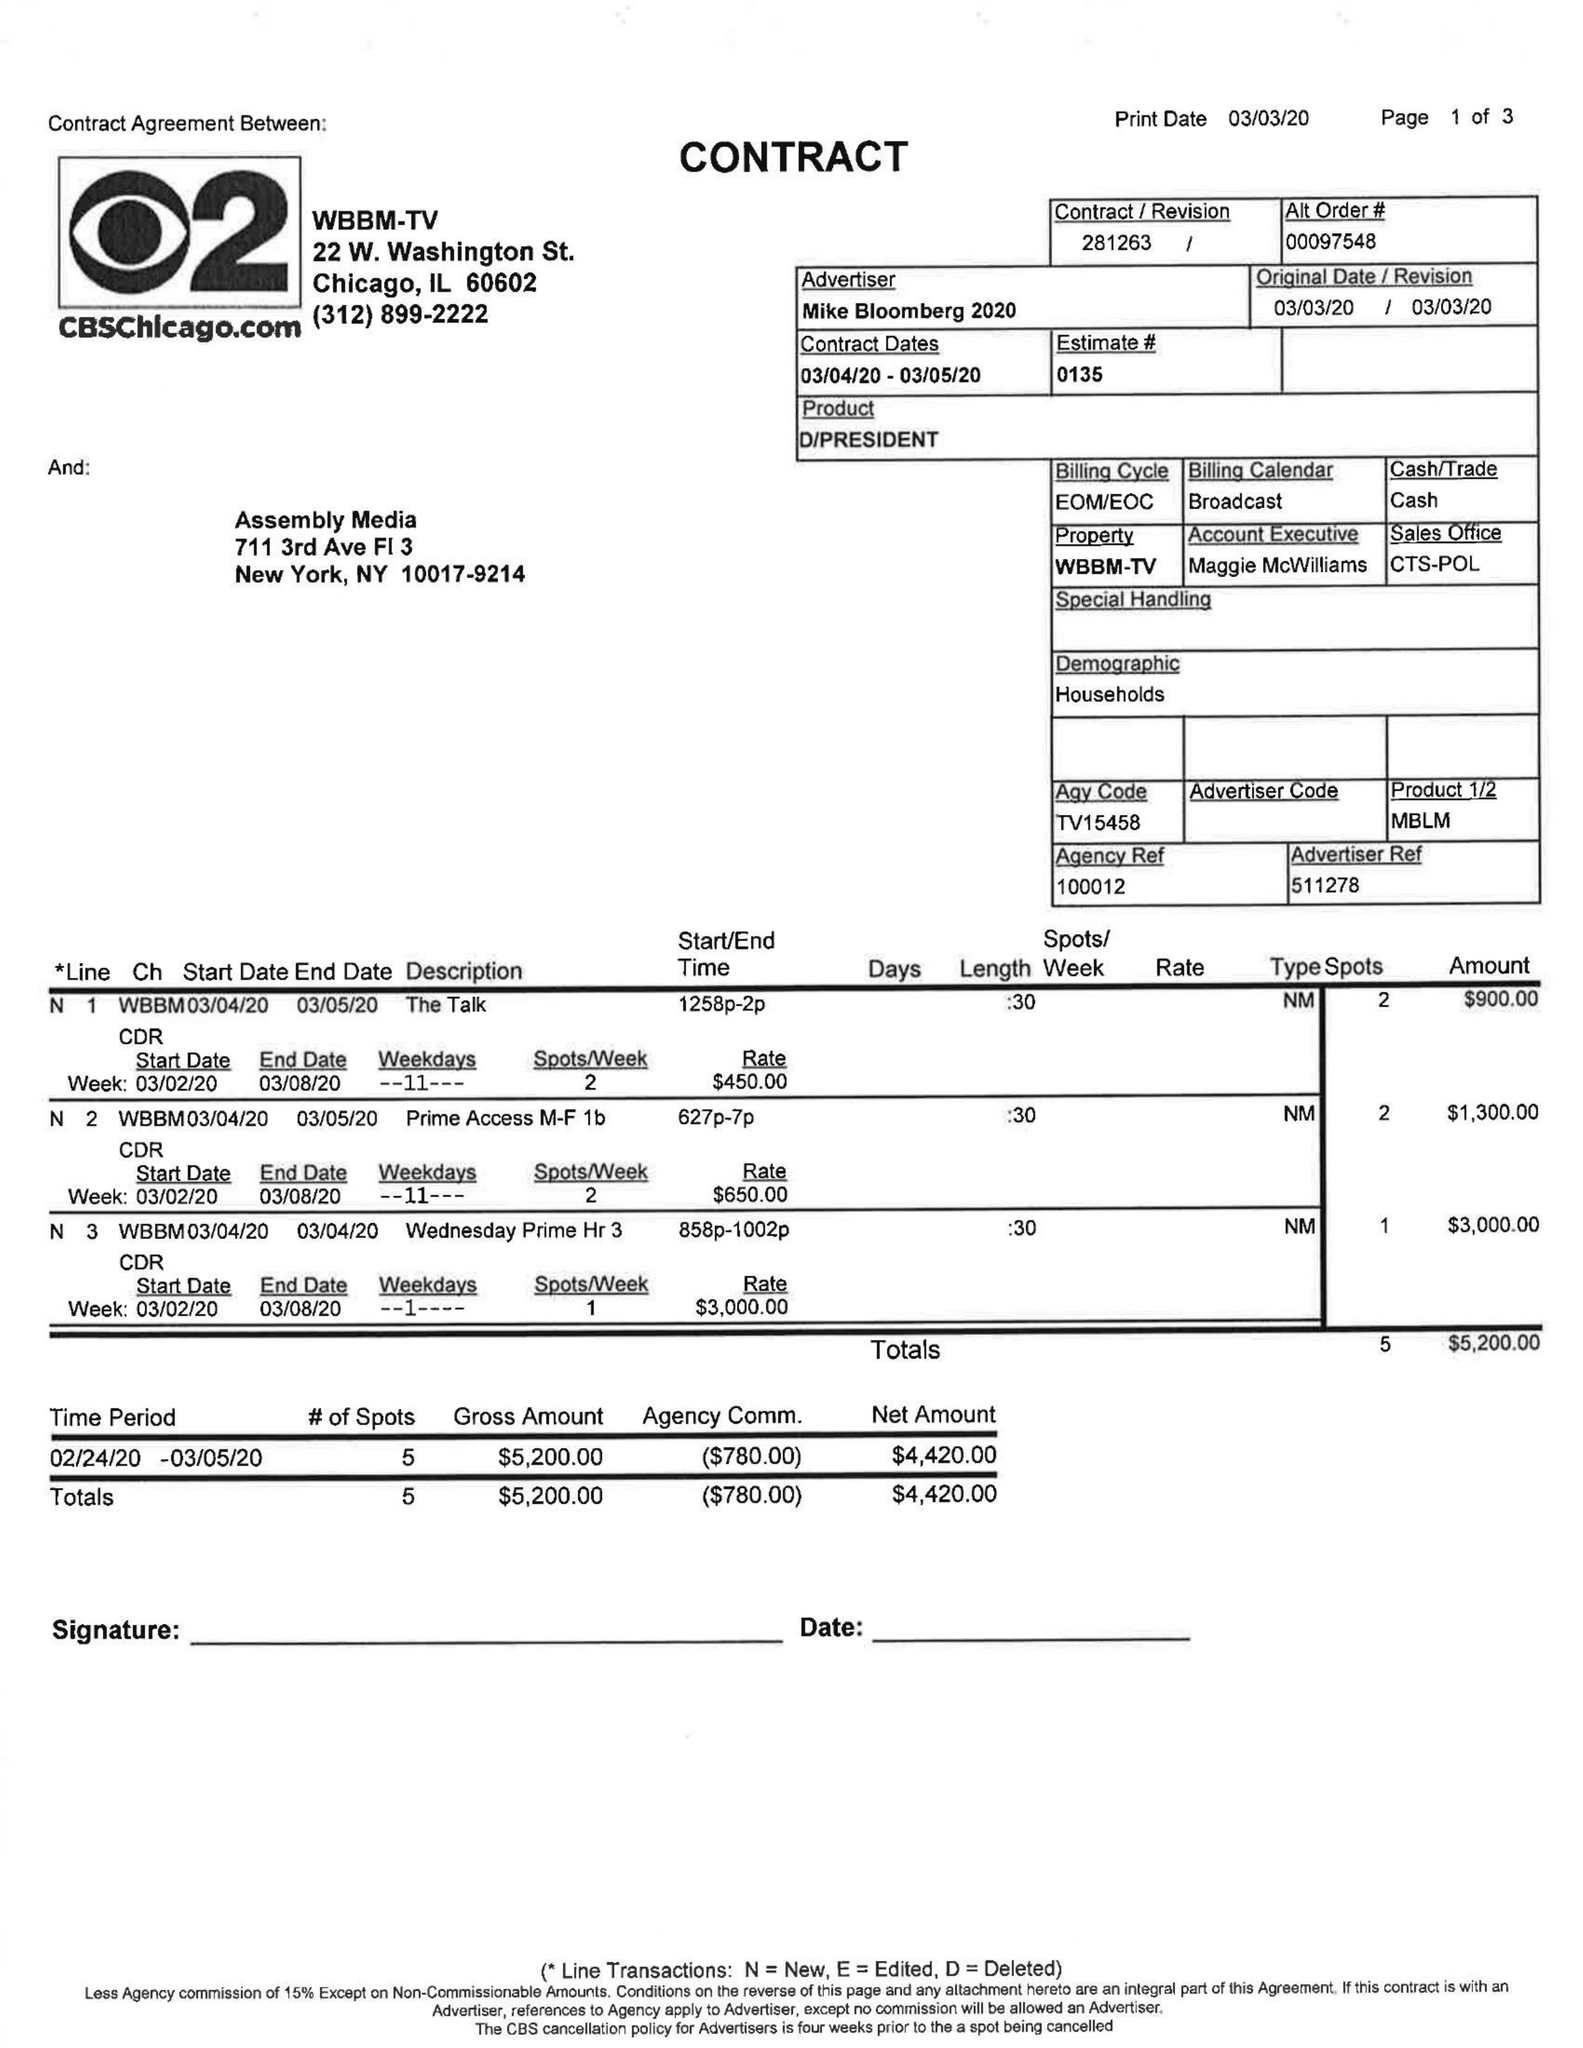What is the value for the flight_from?
Answer the question using a single word or phrase. 03/04/20 